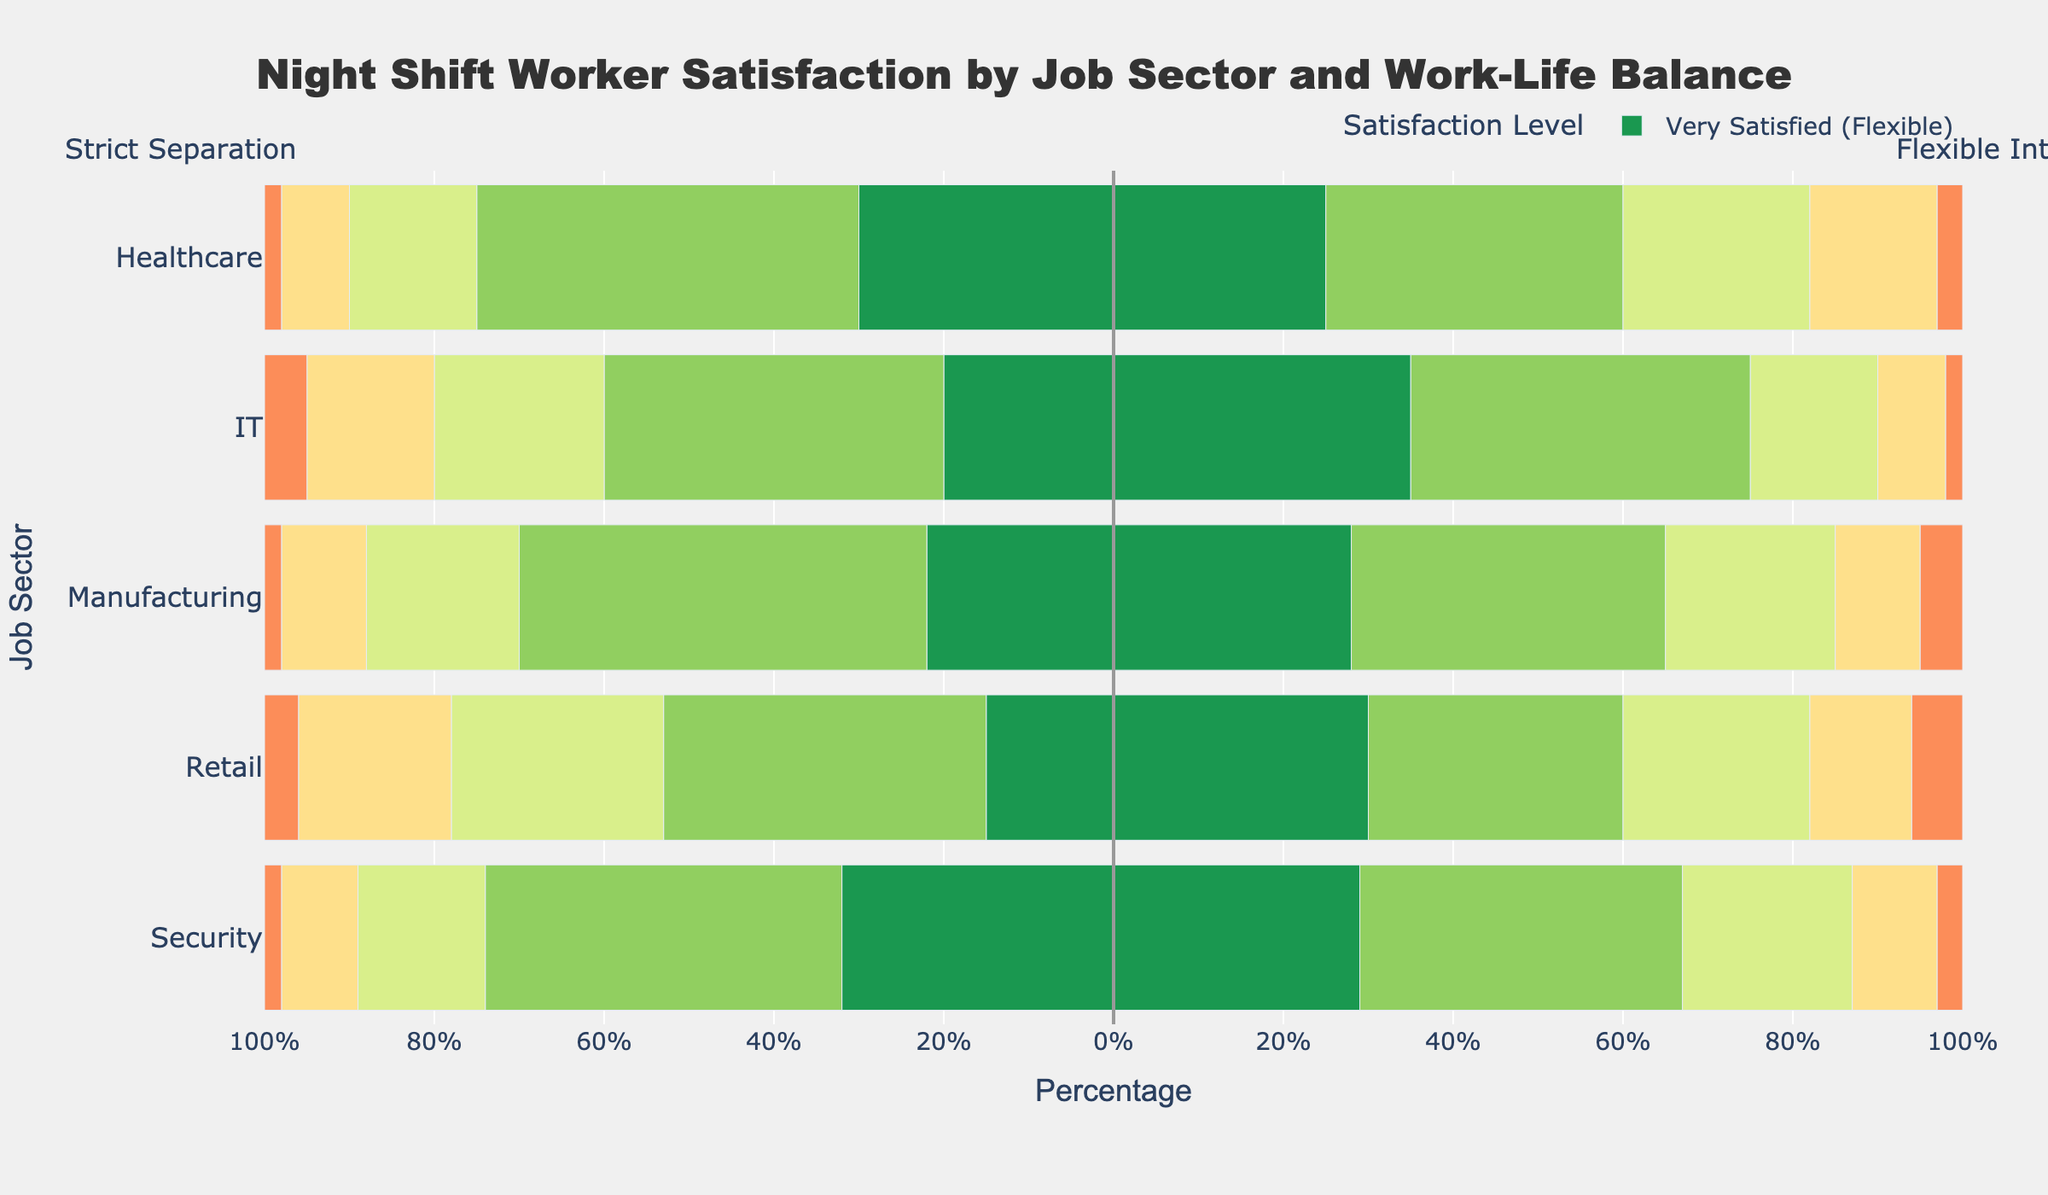What job sector has the highest percentage of "Very Satisfied" night shift workers with a preference for strict separation? Look at the "Very Satisfied (Strict)" bars, and identify the longest one. The Healthcare sector has the highest percentage at 30%.
Answer: Healthcare How does the percentage of "Satisfied" night shift workers in the IT sector compare between strict separation and flexible integration? Compare the lengths of the "Satisfied (Strict)" and "Satisfied (Flexible)" bars for IT. The percentage for strict separation is 40%, and for flexible integration, it is also 40%. Both percentages are equal.
Answer: Equal Which job sector shows the greatest difference in "Neutral" satisfaction levels between strict separation and flexible integration? Find the difference in percentages for "Neutral" bars between strict and flexible for each sector. The differences are: Healthcare (7), IT (5), Manufacturing (2), Retail (3), Security (5). Healthcare has the greatest difference.
Answer: Healthcare What is the combined percentage of night shift workers in the retail sector who are either "Dissatisfied" or "Very Dissatisfied" under strict separation? Add the percentages of "Dissatisfied" and "Very Dissatisfied" for strict separation in Retail. The values are 18% + 4%, resulting in a combined percentage of 22%.
Answer: 22% Between "Flexible Integration" and "Strict Separation," which work-life balance preference yields a higher percentage of "Very Satisfied" night shift workers in the security sector? Compare the "Very Satisfied (Flexible)" and "Very Satisfied (Strict)" bars for the security sector. Flexible integration shows 29%, while strict separation shows 32%. Strict separation yields a higher percentage.
Answer: Strict Separation How does the percentage of "Very Dissatisfied" night shift workers in the manufacturing sector compare between strict separation and flexible integration? Compare the lengths of the "Very Dissatisfied (Strict)" and "Very Dissatisfied (Flexible)" bars for manufacturing. The percentage for strict separation is 2%, and for flexible integration, it is 5%. Flexible integration has a higher percentage.
Answer: Flexible Integration What job sector has the lowest percentage of "Neutral" night shift workers with a preference for flexible integration? Look at the lengths of the "Neutral (Flexible)" bars for all job sectors. The IT sector has the shortest bar with 15%.
Answer: IT In which job sector is the percentage of "Satisfied" night shift workers with a preference for strict separation the highest? Identify the longest "Satisfied (Strict)" bar among all sectors. Manufacturing has the highest percentage at 48%.
Answer: Manufacturing What is the total percentage of "Neutral" satisfaction levels for all job sectors combined, under flexible integration? Sum the percentages of "Neutral (Flexible)" bars across all sectors: 22% (Healthcare) + 15% (IT) + 20% (Manufacturing) + 22% (Retail) + 20% (Security) = 99%.
Answer: 99% Which job sector and work-life balance preference combination has the highest overall satisfaction (Very Satisfied and Satisfied combined)? Sum the percentages of "Very Satisfied" and "Satisfied" for both strict and flexible preferences in all sectors. Compare the sums and find the highest. For the Security sector with strict separation, the combined satisfaction level is 32% + 42% = 74%.
Answer: Security, Strict Separation 